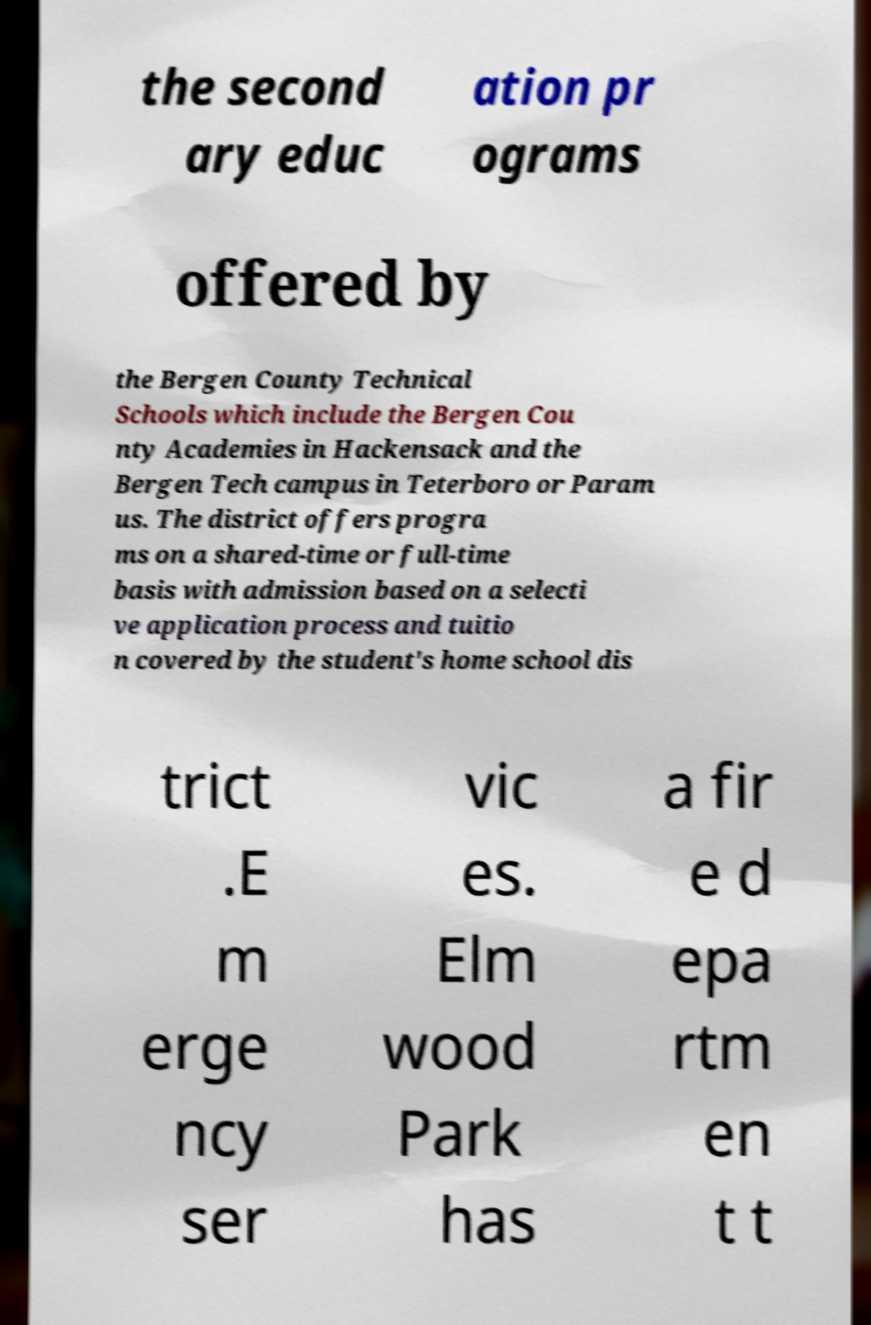What messages or text are displayed in this image? I need them in a readable, typed format. the second ary educ ation pr ograms offered by the Bergen County Technical Schools which include the Bergen Cou nty Academies in Hackensack and the Bergen Tech campus in Teterboro or Param us. The district offers progra ms on a shared-time or full-time basis with admission based on a selecti ve application process and tuitio n covered by the student's home school dis trict .E m erge ncy ser vic es. Elm wood Park has a fir e d epa rtm en t t 